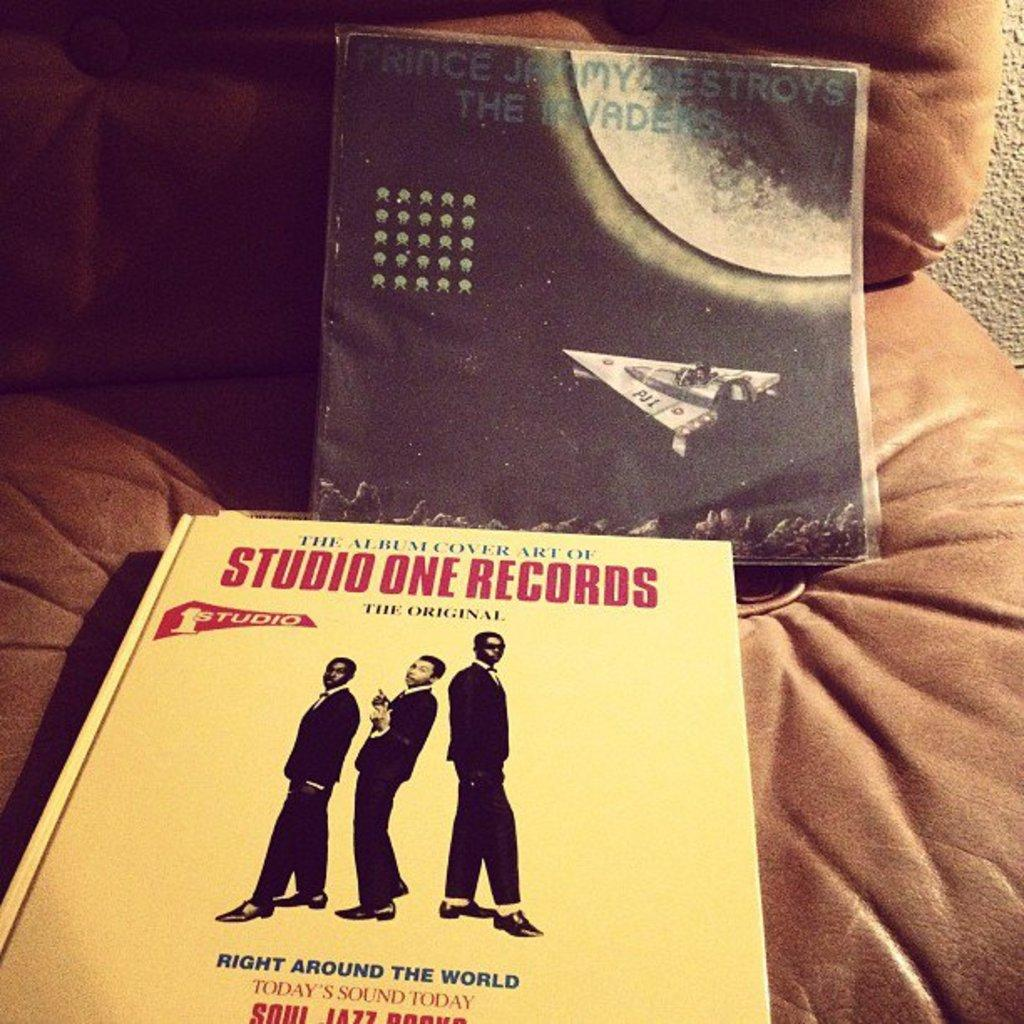<image>
Present a compact description of the photo's key features. A book covers the album cover art of Studio One Records. 